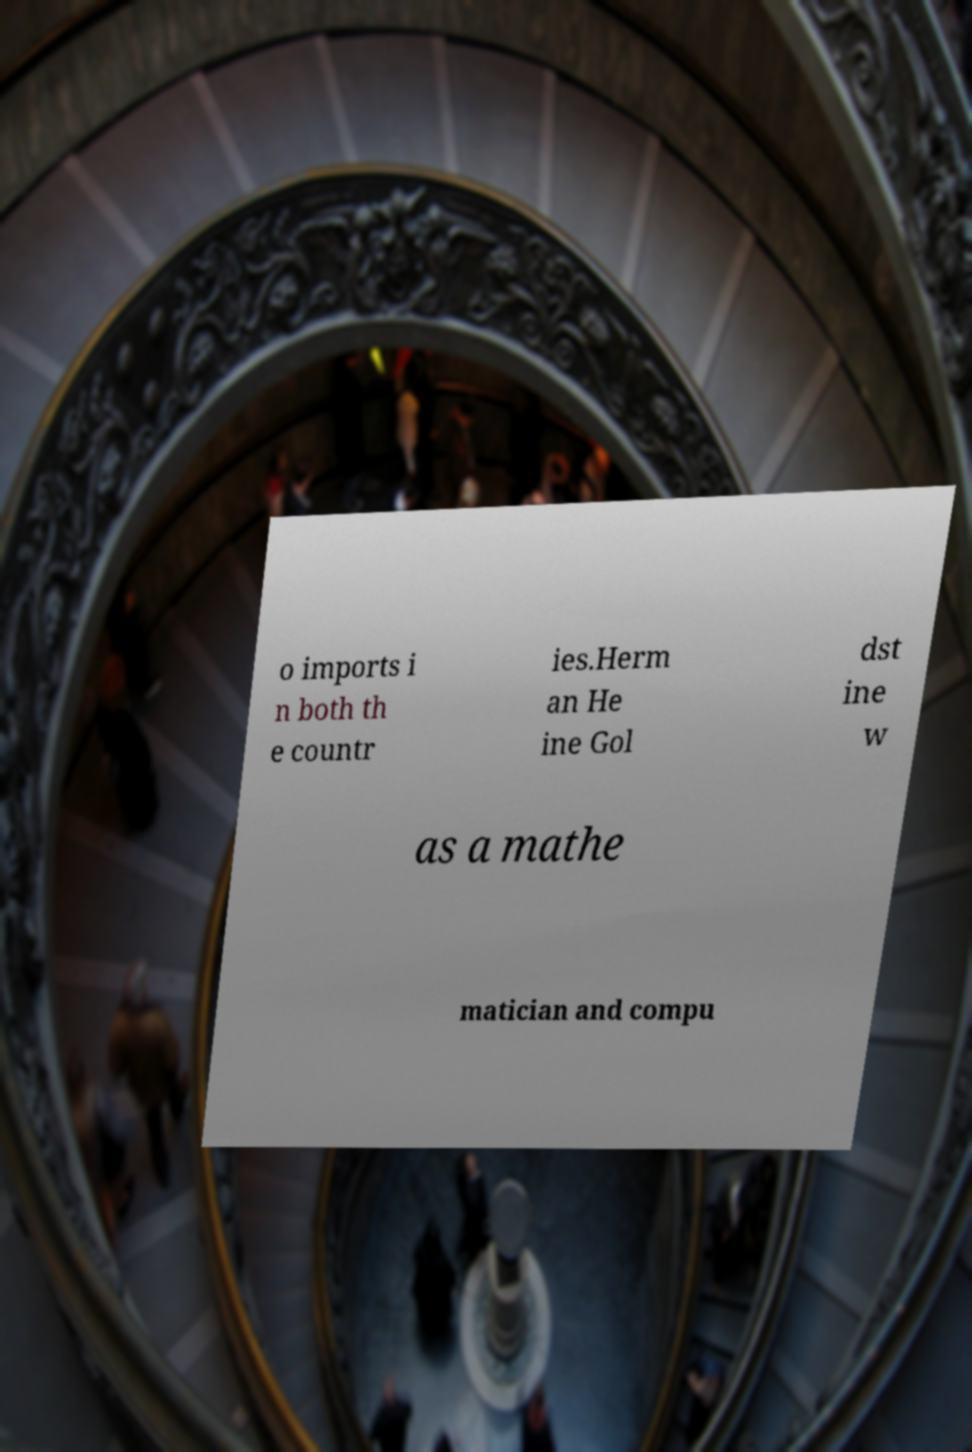Please identify and transcribe the text found in this image. o imports i n both th e countr ies.Herm an He ine Gol dst ine w as a mathe matician and compu 